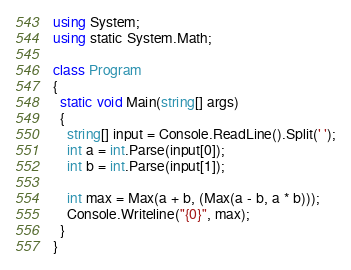Convert code to text. <code><loc_0><loc_0><loc_500><loc_500><_C#_>using System;
using static System.Math;

class Program
{
  static void Main(string[] args)
  {
    string[] input = Console.ReadLine().Split(' ');
    int a = int.Parse(input[0]);
    int b = int.Parse(input[1]);
    
    int max = Max(a + b, (Max(a - b, a * b)));
    Console.Writeline("{0}", max);
  }
}   </code> 